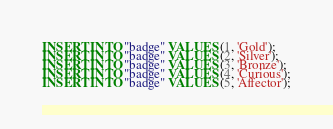<code> <loc_0><loc_0><loc_500><loc_500><_SQL_>INSERT INTO "badge" VALUES (1, 'Gold');
INSERT INTO "badge" VALUES (2, 'Silver');
INSERT INTO "badge" VALUES (3, 'Bronze');
INSERT INTO "badge" VALUES (4, 'Curious');
INSERT INTO "badge" VALUES (5, 'Affector');</code> 